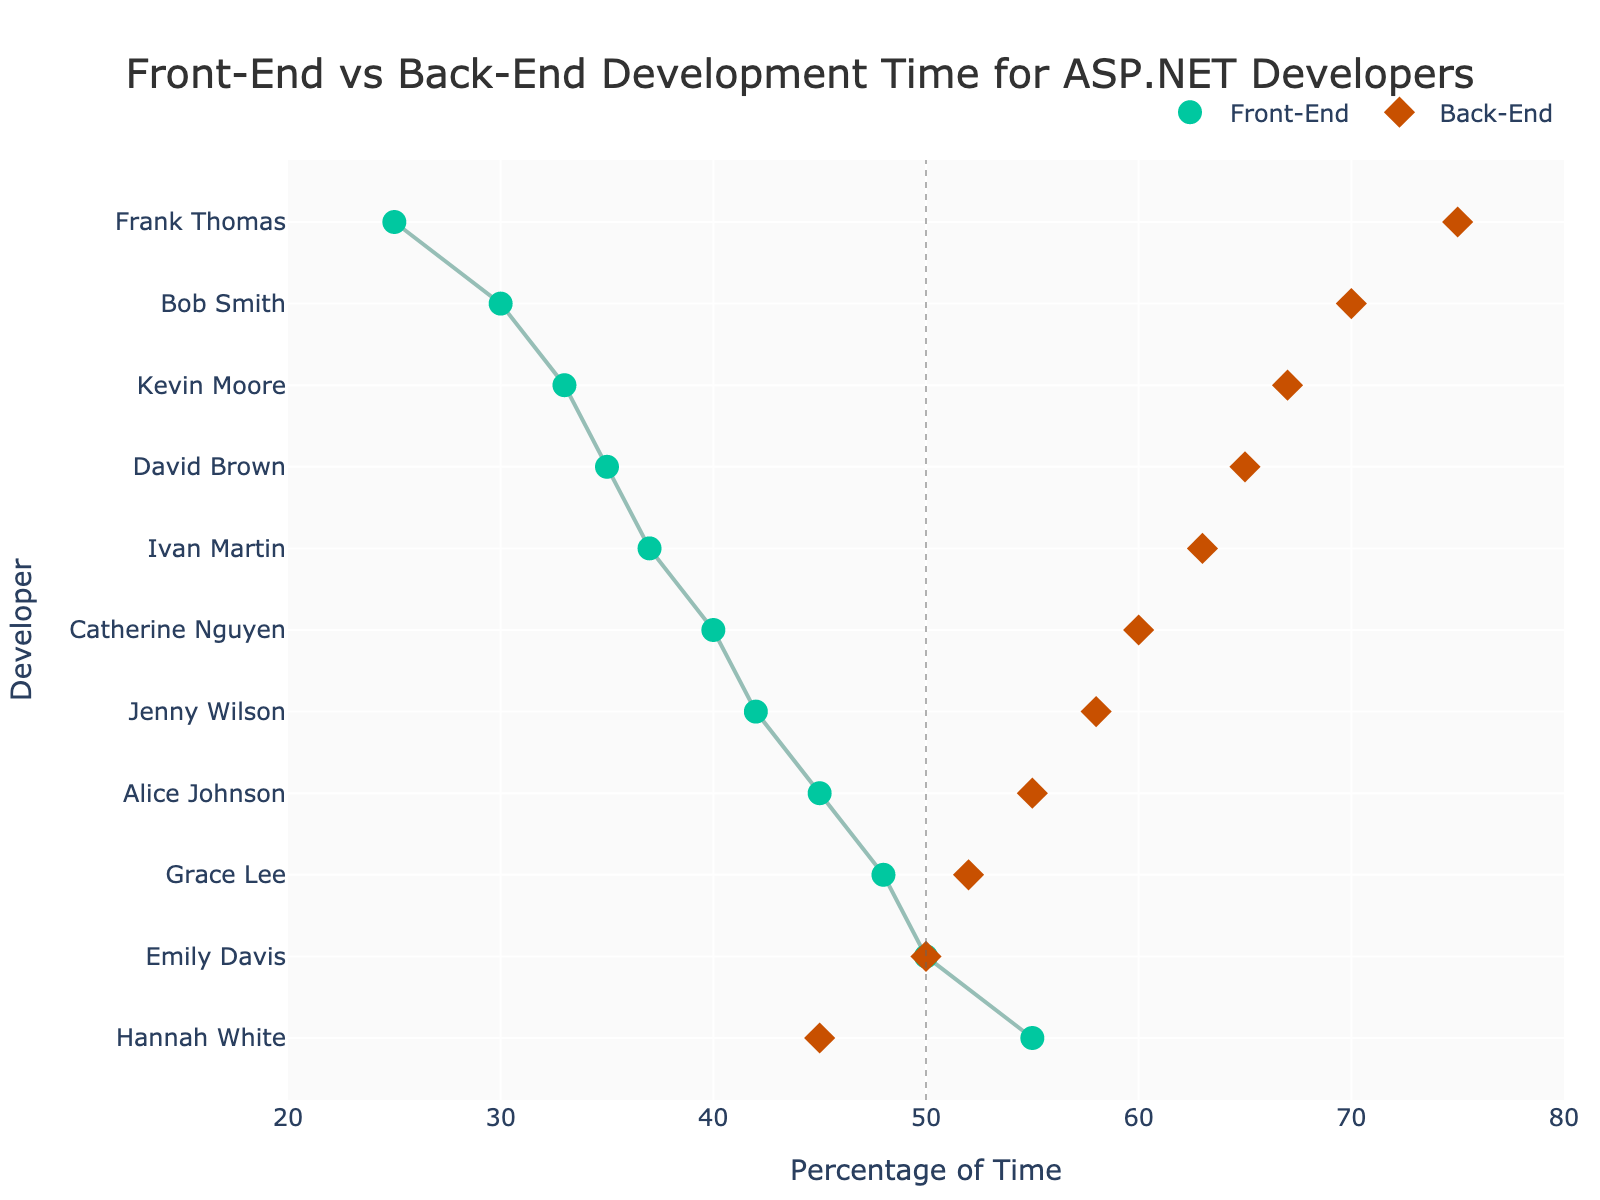What is the title of the figure? The title is located at the top of the figure and reads "Front-End vs Back-End Development Time for ASP.NET Developers".
Answer: Front-End vs Back-End Development Time for ASP.NET Developers Which developer spends the highest percentage of time on Front-End development? By looking at the horizontal markers under the Front-End section on the x-axis, Hannah White spends the highest percentage of time on Front-End development at 55%.
Answer: Hannah White What is the range of percentages shown on the x-axis? The x-axis ranges from 20% to 80%, as indicated by the labels at both ends of the axis.
Answer: 20% to 80% How many developers spend more than 50% of their time on Front-End development? The developers with Front-End percentages above 50% have markers positioned to the right of the vertical 50% line. These developers are Hannah White and Emily Davis, making a total of 2 developers.
Answer: 2 Who spends an equal amount of time on Front-End and Back-End development? The developer with markers aligned at both 50% on the x-axis is Emily Davis, indicating she spends equal time on Front-End and Back-End tasks.
Answer: Emily Davis What is the difference in Front-End development time between the developer who spends the most and the one who spends the least? Hannah White spends 55% of her time on Front-End, while Frank Thomas spends the least at 25%. The difference is calculated by 55% - 25%.
Answer: 30% Which developer shows the largest discrepancy between Front-End and Back-End development time? The largest discrepancy can be observed by the distance between the markers. Frank Thomas has the largest discrepancy, with 25% in Front-End and 75% in Back-End, which is a difference of 50%.
Answer: Frank Thomas What is the average percentage of time spent on Front-End development across all developers? The sum of the percentages is 45 + 30 + 40 + 35 + 50 + 25 + 48 + 55 + 37 + 42 + 33 = 440. There are 11 developers, so the average is calculated as 440 / 11.
Answer: 40% Which developer has a 70% allocation for Back-End development and what's their Front-End percentage? By examining developers who spend 70% of their time on Back-End tasks, Bob Smith is identified, who has a 30% allocation for Front-End development.
Answer: Bob Smith, 30% 